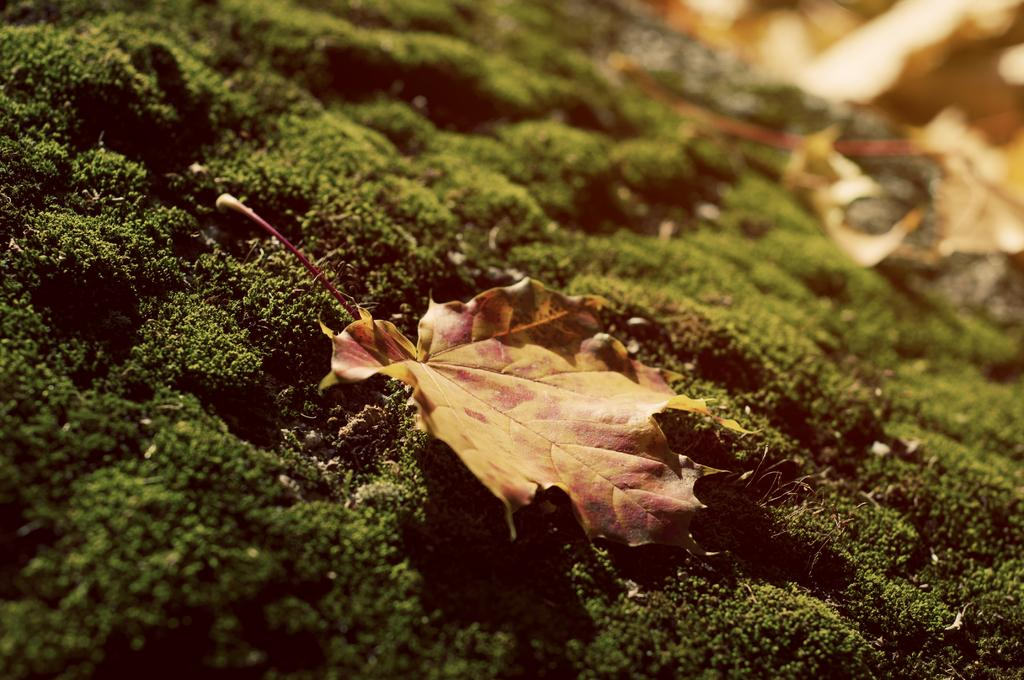What type of vegetation can be seen in the image? There is grass in the image. What other natural element is present in the image? There is a leaf in the image. How would you describe the background of the image? The background of the image is blurry. What type of account is being discussed in the image? There is no account being discussed in the image; it features grass and a leaf. 